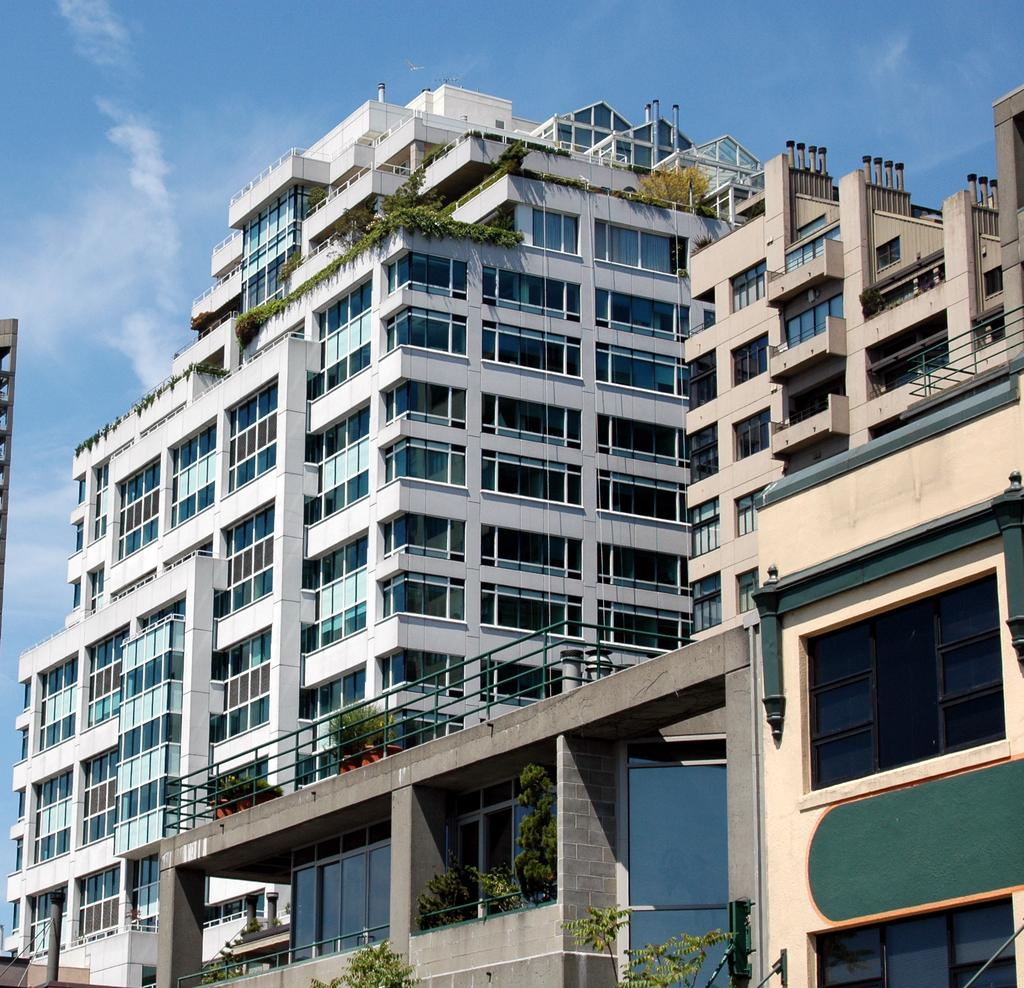What structures can be seen in the image? There are buildings in the image. What is growing on the buildings? There are plants on the buildings. How would you describe the sky in the image? The sky is cloudy. How many pens are visible on the buildings in the image? There are no pens visible on the buildings in the image. What type of fingerprints can be seen on the plants in the image? There are no fingerprints present in the image, as it features buildings with plants and a cloudy sky. 